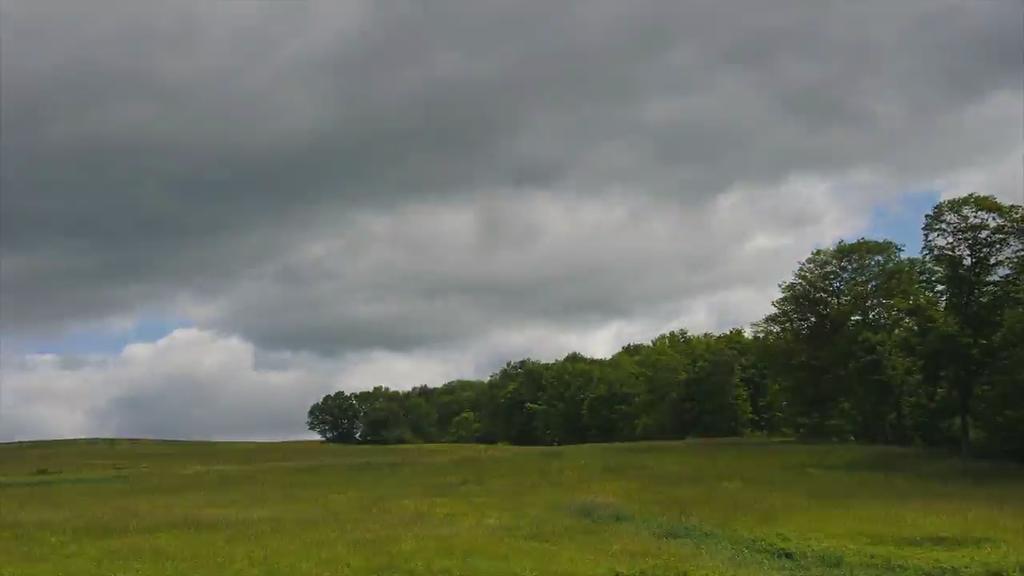Describe this image in one or two sentences. In this picture we can see grass and trees. In the background of the image we can see the sky with clouds. 